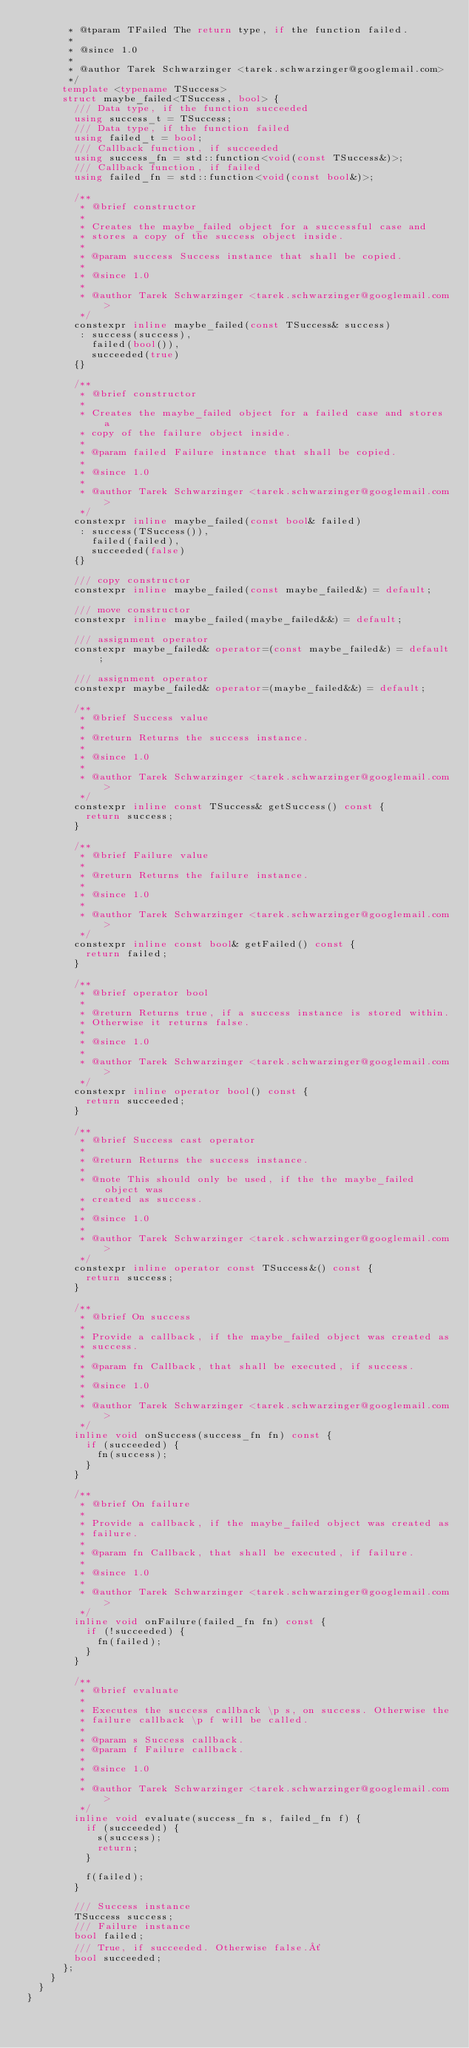<code> <loc_0><loc_0><loc_500><loc_500><_C++_>       * @tparam TFailed The return type, if the function failed.
       *
       * @since 1.0
       *
       * @author Tarek Schwarzinger <tarek.schwarzinger@googlemail.com>
       */
      template <typename TSuccess>
      struct maybe_failed<TSuccess, bool> {
        /// Data type, if the function succeeded
        using success_t = TSuccess;
        /// Data type, if the function failed
        using failed_t = bool;
        /// Callback function, if succeeded
        using success_fn = std::function<void(const TSuccess&)>;
        /// Callback function, if failed
        using failed_fn = std::function<void(const bool&)>;

        /**
         * @brief constructor
         *
         * Creates the maybe_failed object for a successful case and
         * stores a copy of the success object inside.
         *
         * @param success Success instance that shall be copied.
         *
         * @since 1.0
         *
         * @author Tarek Schwarzinger <tarek.schwarzinger@googlemail.com>
         */
        constexpr inline maybe_failed(const TSuccess& success)
         : success(success),
           failed(bool()),
           succeeded(true)
        {}

        /**
         * @brief constructor
         *
         * Creates the maybe_failed object for a failed case and stores a
         * copy of the failure object inside.
         *
         * @param failed Failure instance that shall be copied.
         *
         * @since 1.0
         *
         * @author Tarek Schwarzinger <tarek.schwarzinger@googlemail.com>
         */
        constexpr inline maybe_failed(const bool& failed)
         : success(TSuccess()),
           failed(failed),
           succeeded(false)
        {}

        /// copy constructor
        constexpr inline maybe_failed(const maybe_failed&) = default;

        /// move constructor
        constexpr inline maybe_failed(maybe_failed&&) = default;

        /// assignment operator
        constexpr maybe_failed& operator=(const maybe_failed&) = default;

        /// assignment operator
        constexpr maybe_failed& operator=(maybe_failed&&) = default;

        /**
         * @brief Success value
         *
         * @return Returns the success instance.
         *
         * @since 1.0
         *
         * @author Tarek Schwarzinger <tarek.schwarzinger@googlemail.com>
         */
        constexpr inline const TSuccess& getSuccess() const {
          return success;
        }

        /**
         * @brief Failure value
         *
         * @return Returns the failure instance.
         *
         * @since 1.0
         *
         * @author Tarek Schwarzinger <tarek.schwarzinger@googlemail.com>
         */
        constexpr inline const bool& getFailed() const {
          return failed;
        }

        /**
         * @brief operator bool
         *
         * @return Returns true, if a success instance is stored within.
         * Otherwise it returns false.
         *
         * @since 1.0
         *
         * @author Tarek Schwarzinger <tarek.schwarzinger@googlemail.com>
         */
        constexpr inline operator bool() const {
          return succeeded;
        }

        /**
         * @brief Success cast operator
         *
         * @return Returns the success instance.
         *
         * @note This should only be used, if the the maybe_failed object was
         * created as success.
         *
         * @since 1.0
         *
         * @author Tarek Schwarzinger <tarek.schwarzinger@googlemail.com>
         */
        constexpr inline operator const TSuccess&() const {
          return success;
        }

        /**
         * @brief On success
         *
         * Provide a callback, if the maybe_failed object was created as
         * success.
         *
         * @param fn Callback, that shall be executed, if success.
         *
         * @since 1.0
         *
         * @author Tarek Schwarzinger <tarek.schwarzinger@googlemail.com>
         */
        inline void onSuccess(success_fn fn) const {
          if (succeeded) {
            fn(success);
          }
        }

        /**
         * @brief On failure
         *
         * Provide a callback, if the maybe_failed object was created as
         * failure.
         *
         * @param fn Callback, that shall be executed, if failure.
         *
         * @since 1.0
         *
         * @author Tarek Schwarzinger <tarek.schwarzinger@googlemail.com>
         */
        inline void onFailure(failed_fn fn) const {
          if (!succeeded) {
            fn(failed);
          }
        }

        /**
         * @brief evaluate
         *
         * Executes the success callback \p s, on success. Otherwise the
         * failure callback \p f will be called.
         *
         * @param s Success callback.
         * @param f Failure callback.
         *
         * @since 1.0
         *
         * @author Tarek Schwarzinger <tarek.schwarzinger@googlemail.com>
         */
        inline void evaluate(success_fn s, failed_fn f) {
          if (succeeded) {
            s(success);
            return;
          }

          f(failed);
        }

        /// Success instance
        TSuccess success;
        /// Failure instance
        bool failed;
        /// True, if succeeded. Otherwise false.´
        bool succeeded;
      };
    }
  }
}
</code> 